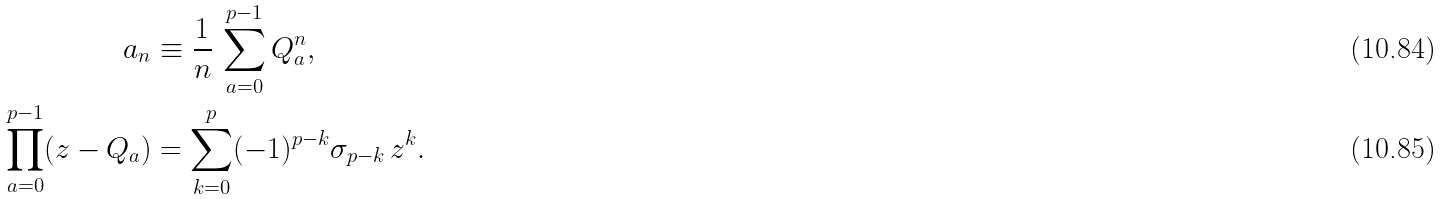<formula> <loc_0><loc_0><loc_500><loc_500>a _ { n } & \equiv \frac { 1 } { n } \, \sum _ { a = 0 } ^ { p - 1 } Q _ { a } ^ { n } , \\ \prod _ { a = 0 } ^ { p - 1 } ( z - Q _ { a } ) & = \sum _ { k = 0 } ^ { p } ( - 1 ) ^ { p - k } \sigma _ { p - k } \, z ^ { k } .</formula> 